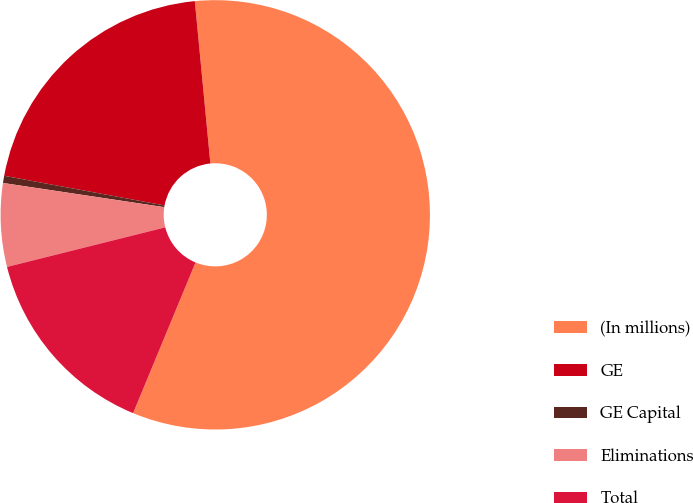Convert chart. <chart><loc_0><loc_0><loc_500><loc_500><pie_chart><fcel>(In millions)<fcel>GE<fcel>GE Capital<fcel>Eliminations<fcel>Total<nl><fcel>57.77%<fcel>20.57%<fcel>0.54%<fcel>6.27%<fcel>14.85%<nl></chart> 